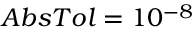Convert formula to latex. <formula><loc_0><loc_0><loc_500><loc_500>A b s T o l = 1 0 ^ { - 8 }</formula> 